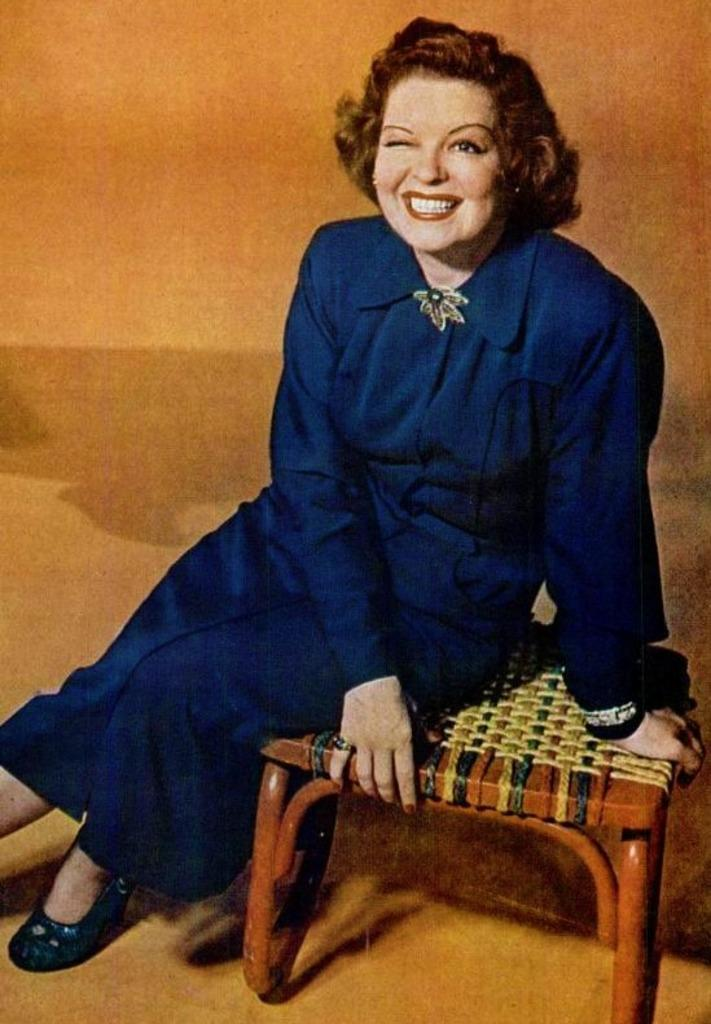What is the main subject of the image? The main subject of the image is a woman. What is the woman wearing in the image? The woman is wearing a blue dress in the image. What is the woman sitting on in the image? The woman is sitting on a stool in the image. Where is the stool placed in the image? The stool is placed on the floor in the image. Can you see a robin perched on the woman's shoulder in the image? No, there is no robin present in the image. What type of string is tied around the woman's waist in the image? There is no string tied around the woman's waist in the image. 